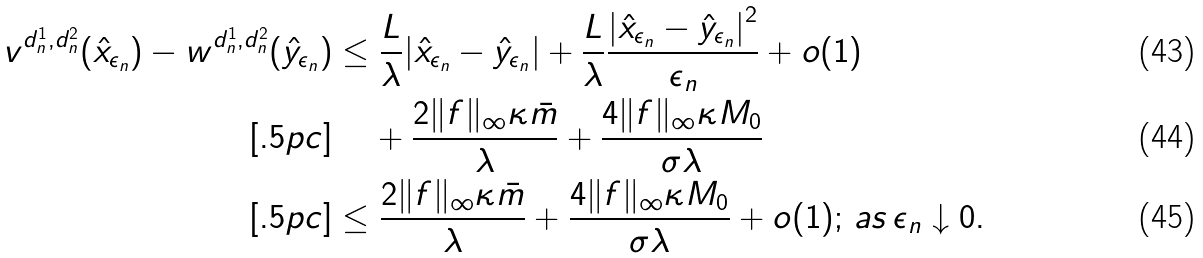Convert formula to latex. <formula><loc_0><loc_0><loc_500><loc_500>v ^ { d ^ { 1 } _ { n } , d ^ { 2 } _ { n } } ( \hat { x } _ { \epsilon _ { n } } ) - w ^ { d ^ { 1 } _ { n } , d ^ { 2 } _ { n } } ( \hat { y } _ { \epsilon _ { n } } ) & \leq \frac { L } { \lambda } | \hat { x } _ { \epsilon _ { n } } - \hat { y } _ { \epsilon _ { n } } | + \frac { L } { \lambda } \frac { { | \hat { x } _ { \epsilon _ { n } } - \hat { y } _ { \epsilon _ { n } } | } ^ { 2 } } { \epsilon _ { n } } + o ( 1 ) \\ [ . 5 p c ] & \quad \, + \frac { 2 \| f \| _ { \infty } \kappa \bar { m } } { \lambda } + \frac { 4 \| f \| _ { \infty } \kappa M _ { 0 } } { \sigma \lambda } \\ [ . 5 p c ] & \leq \frac { 2 \| f \| _ { \infty } \kappa \bar { m } } { \lambda } + \frac { 4 \| f \| _ { \infty } \kappa M _ { 0 } } { \sigma \lambda } + o ( 1 ) ; \, a s \, \epsilon _ { n } \downarrow 0 .</formula> 